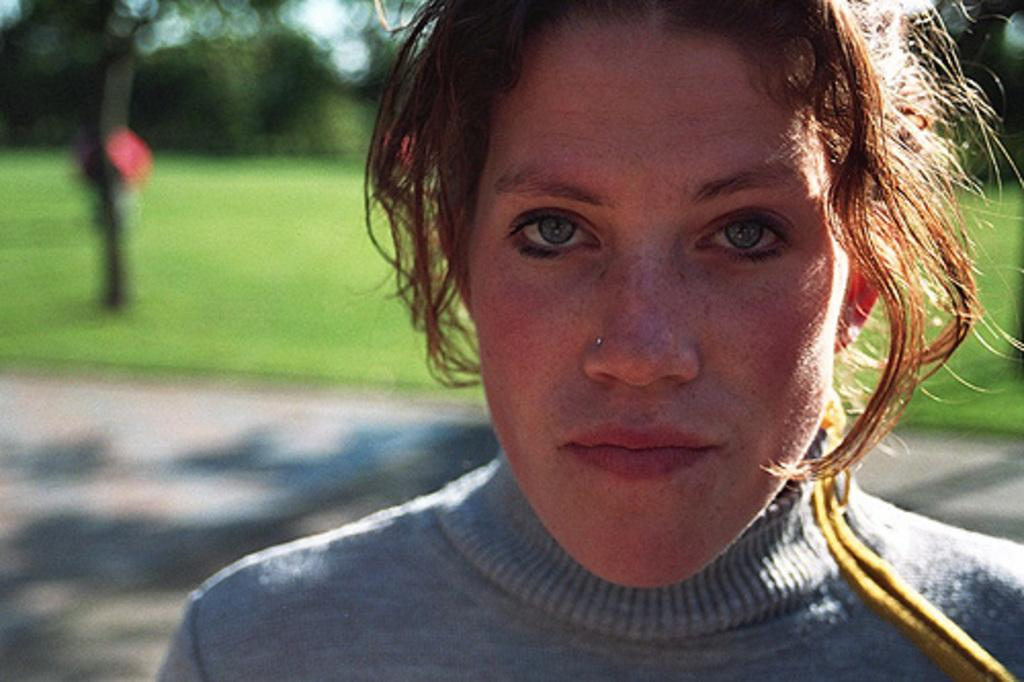Who is the main subject in the image? There is a lady in the image. What accessory is the lady wearing? The lady is wearing a nose stud. Can you describe the background of the image? The background of the image is blurred. What type of laborer is working in the background of the image? There is no laborer present in the image, and the background is blurred, so it is not possible to determine if there is a laborer working. 